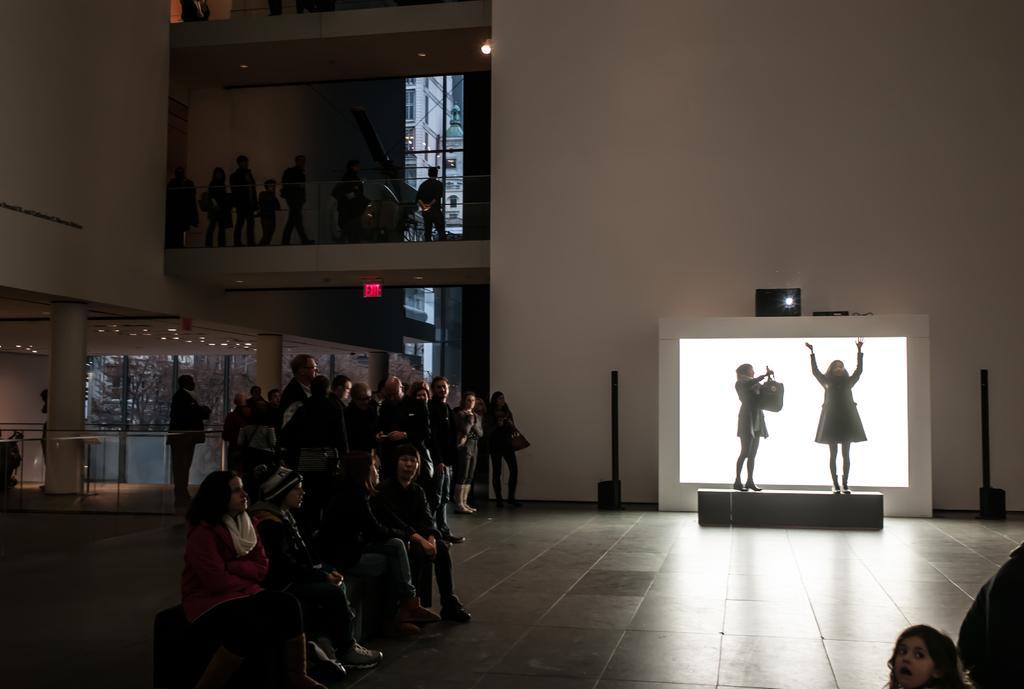How would you summarize this image in a sentence or two? In the foreground of the image we can see some people are sitting. In the middle of the image we can see some people are standing and two people are performing something. On the top of the image we can see some people. 